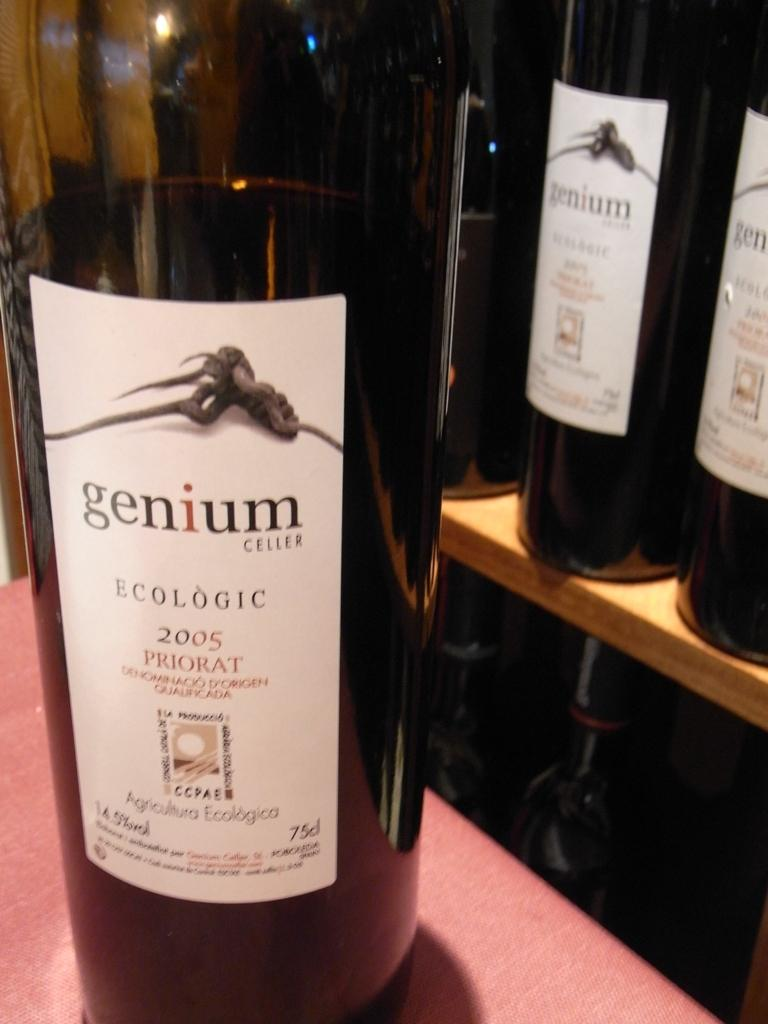<image>
Offer a succinct explanation of the picture presented. A bottle of Ecologic 2005 Priorat from genium cellars. 